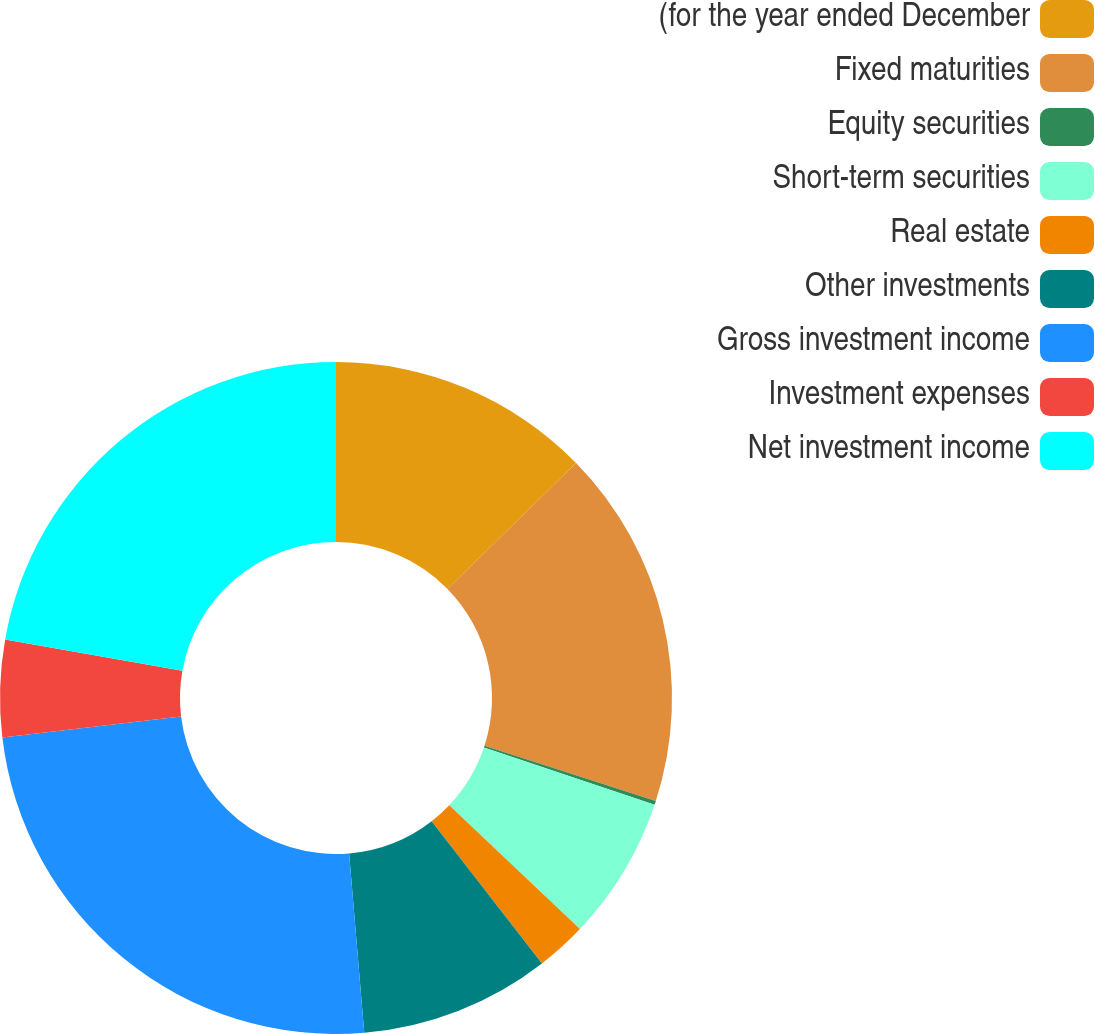Convert chart. <chart><loc_0><loc_0><loc_500><loc_500><pie_chart><fcel>(for the year ended December<fcel>Fixed maturities<fcel>Equity securities<fcel>Short-term securities<fcel>Real estate<fcel>Other investments<fcel>Gross investment income<fcel>Investment expenses<fcel>Net investment income<nl><fcel>12.67%<fcel>17.29%<fcel>0.19%<fcel>6.92%<fcel>2.43%<fcel>9.16%<fcel>24.46%<fcel>4.67%<fcel>22.21%<nl></chart> 